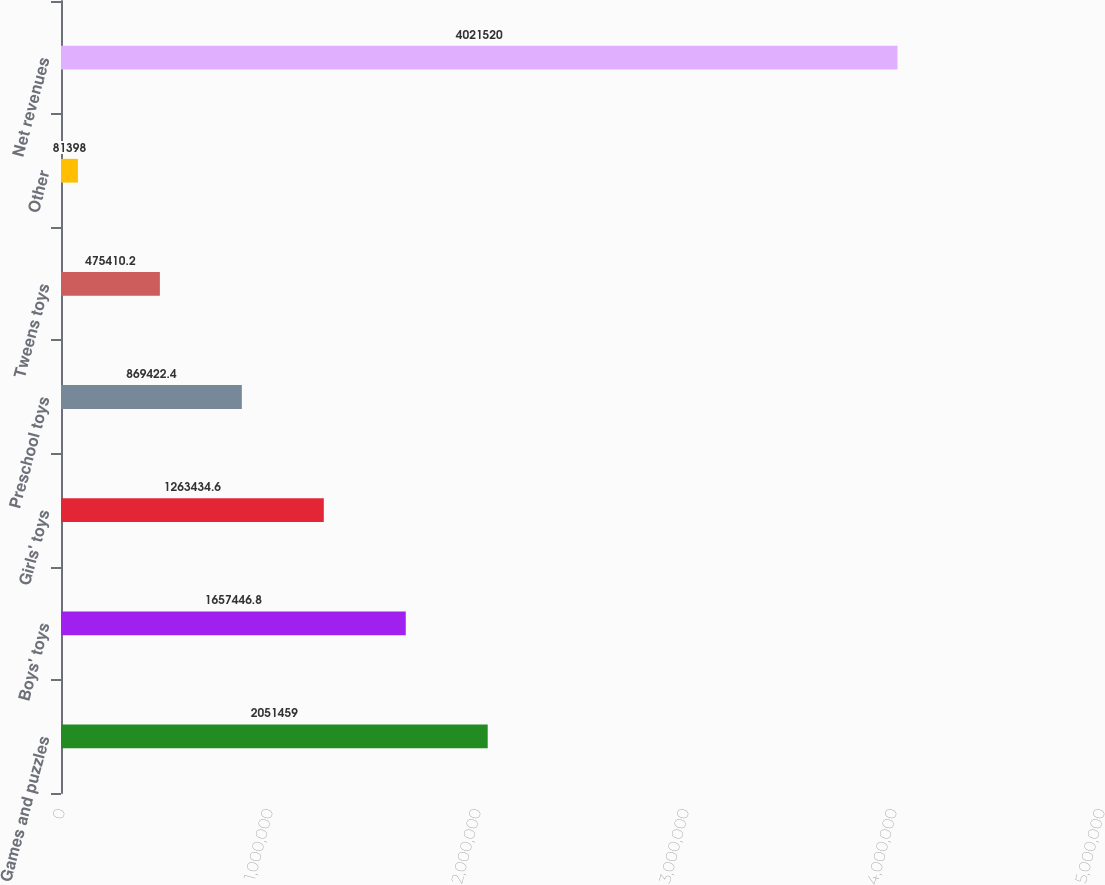Convert chart to OTSL. <chart><loc_0><loc_0><loc_500><loc_500><bar_chart><fcel>Games and puzzles<fcel>Boys' toys<fcel>Girls' toys<fcel>Preschool toys<fcel>Tweens toys<fcel>Other<fcel>Net revenues<nl><fcel>2.05146e+06<fcel>1.65745e+06<fcel>1.26343e+06<fcel>869422<fcel>475410<fcel>81398<fcel>4.02152e+06<nl></chart> 